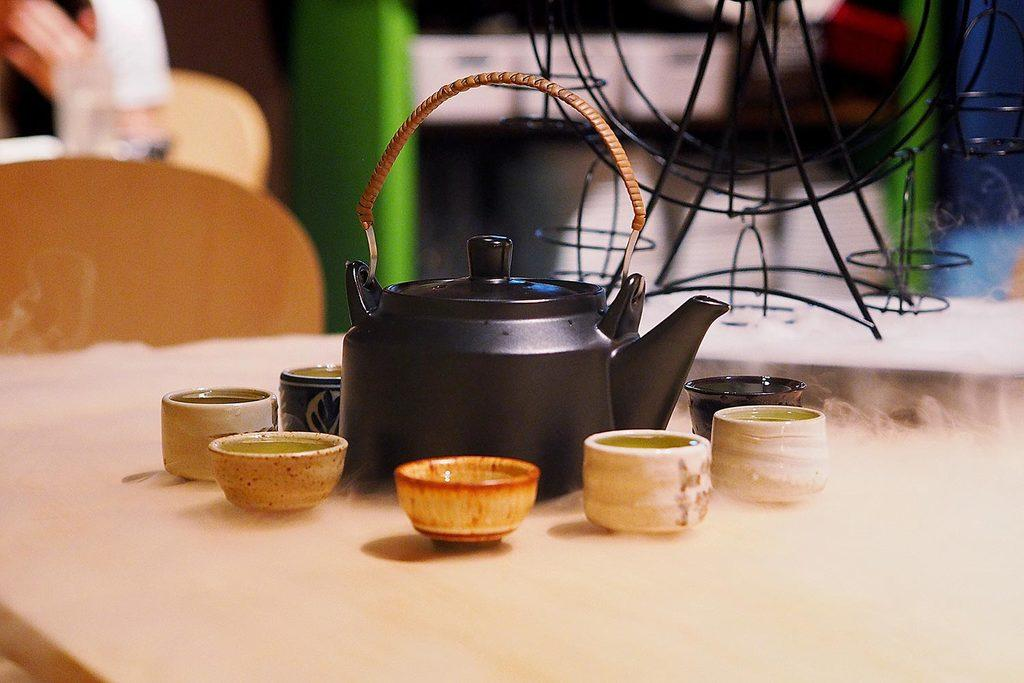What is the main object in the image? There is a tea jug in the image. What is on the table in the image? There are cups and a stand on the table in the image. Can you describe the stand in the image? There are no specific details about the stand provided, but it is present on the table. What else can be found on the table in the image? There are other unspecified things on the table in the image. How many ants are crawling on the tea jug in the image? There is no mention of ants in the image, so it is impossible to determine how many ants are present. 